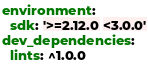<code> <loc_0><loc_0><loc_500><loc_500><_YAML_>environment:
  sdk: '>=2.12.0 <3.0.0'
dev_dependencies:
  lints: ^1.0.0</code> 